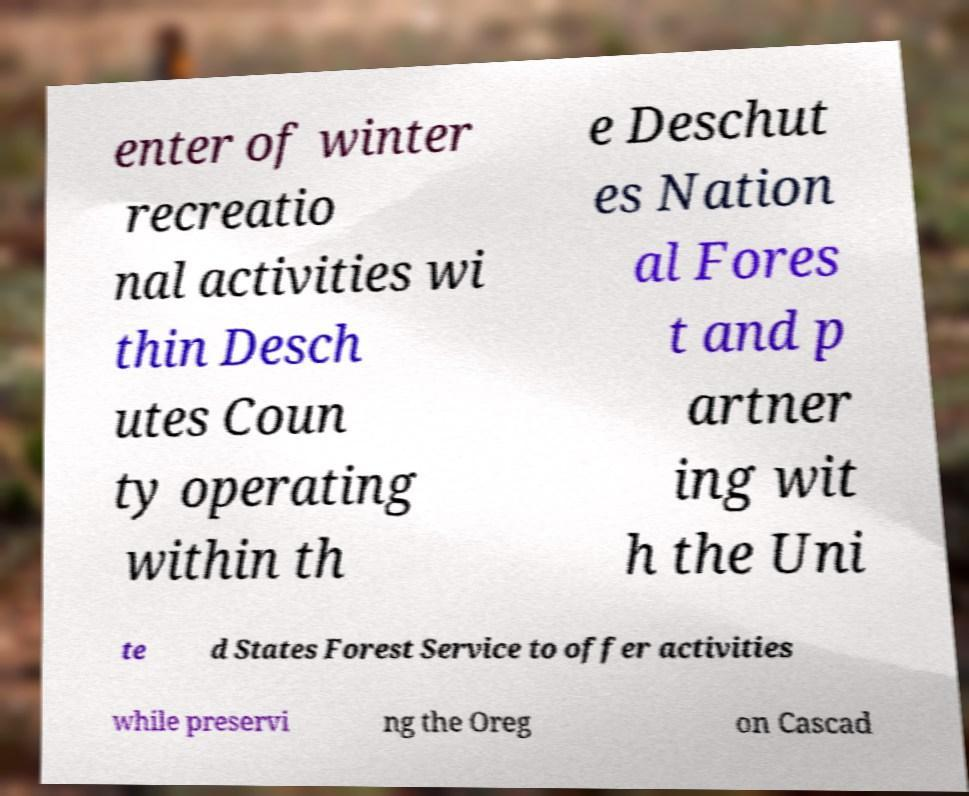Please read and relay the text visible in this image. What does it say? enter of winter recreatio nal activities wi thin Desch utes Coun ty operating within th e Deschut es Nation al Fores t and p artner ing wit h the Uni te d States Forest Service to offer activities while preservi ng the Oreg on Cascad 